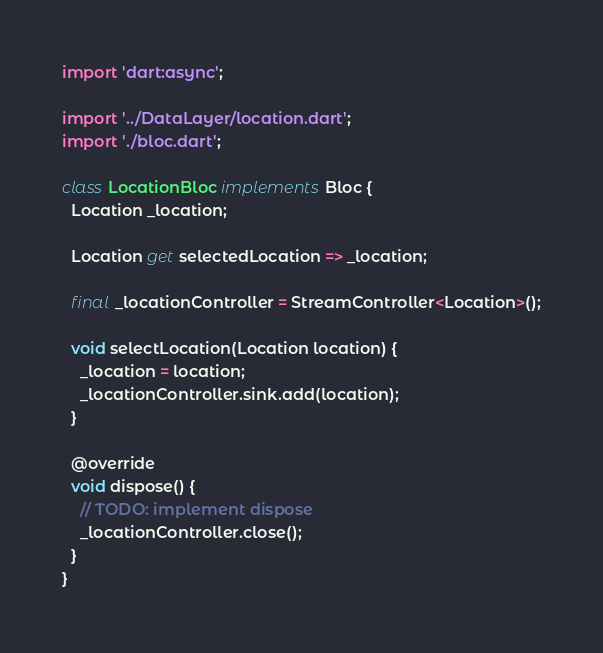<code> <loc_0><loc_0><loc_500><loc_500><_Dart_>import 'dart:async';

import '../DataLayer/location.dart';
import './bloc.dart';

class LocationBloc implements Bloc {
  Location _location;

  Location get selectedLocation => _location;

  final _locationController = StreamController<Location>();

  void selectLocation(Location location) {
    _location = location;
    _locationController.sink.add(location);
  }

  @override
  void dispose() {
    // TODO: implement dispose
    _locationController.close();
  }
}
</code> 